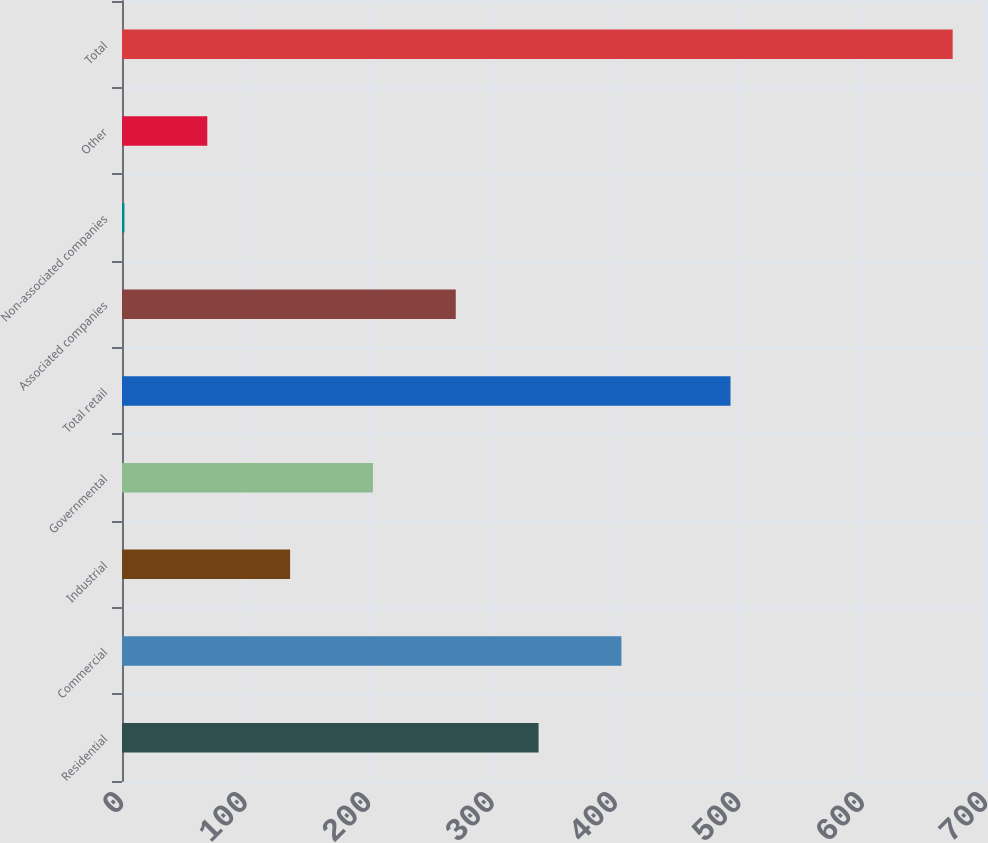Convert chart. <chart><loc_0><loc_0><loc_500><loc_500><bar_chart><fcel>Residential<fcel>Commercial<fcel>Industrial<fcel>Governmental<fcel>Total retail<fcel>Associated companies<fcel>Non-associated companies<fcel>Other<fcel>Total<nl><fcel>337.5<fcel>404.6<fcel>136.2<fcel>203.3<fcel>493<fcel>270.4<fcel>2<fcel>69.1<fcel>673<nl></chart> 